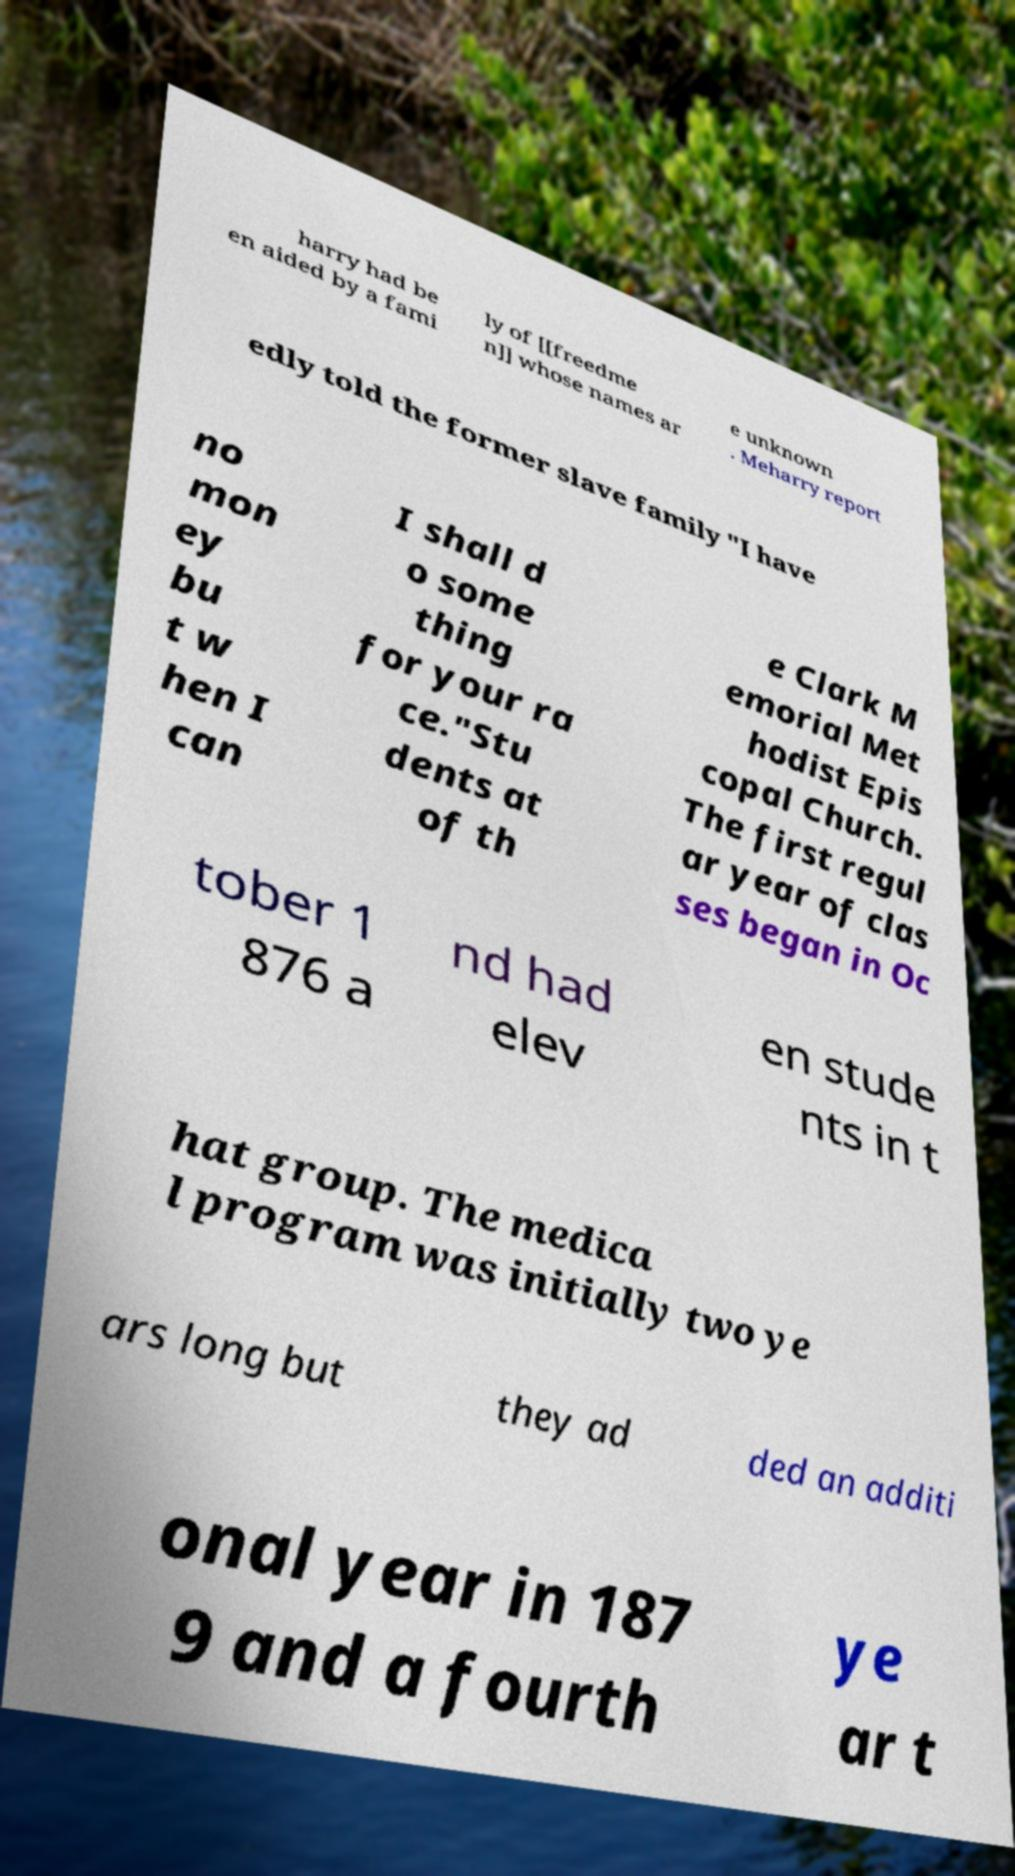Could you assist in decoding the text presented in this image and type it out clearly? harry had be en aided by a fami ly of [[freedme n]] whose names ar e unknown . Meharry report edly told the former slave family "I have no mon ey bu t w hen I can I shall d o some thing for your ra ce."Stu dents at of th e Clark M emorial Met hodist Epis copal Church. The first regul ar year of clas ses began in Oc tober 1 876 a nd had elev en stude nts in t hat group. The medica l program was initially two ye ars long but they ad ded an additi onal year in 187 9 and a fourth ye ar t 